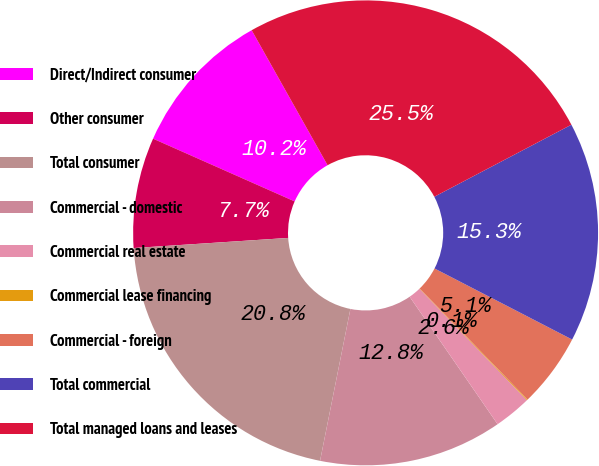<chart> <loc_0><loc_0><loc_500><loc_500><pie_chart><fcel>Direct/Indirect consumer<fcel>Other consumer<fcel>Total consumer<fcel>Commercial - domestic<fcel>Commercial real estate<fcel>Commercial lease financing<fcel>Commercial - foreign<fcel>Total commercial<fcel>Total managed loans and leases<nl><fcel>10.21%<fcel>7.68%<fcel>20.82%<fcel>12.75%<fcel>2.6%<fcel>0.06%<fcel>5.14%<fcel>15.29%<fcel>25.45%<nl></chart> 